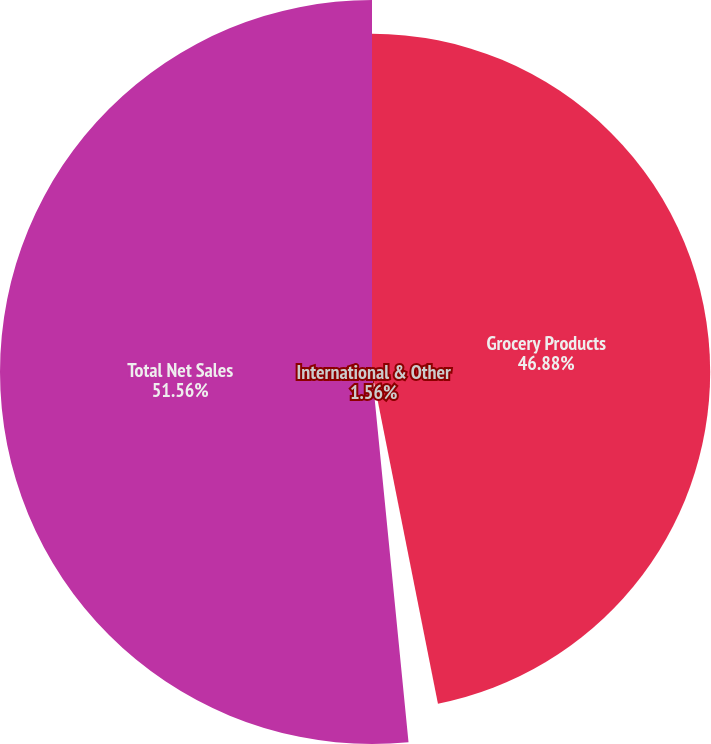Convert chart to OTSL. <chart><loc_0><loc_0><loc_500><loc_500><pie_chart><fcel>Grocery Products<fcel>International & Other<fcel>Total Net Sales<nl><fcel>46.88%<fcel>1.56%<fcel>51.57%<nl></chart> 